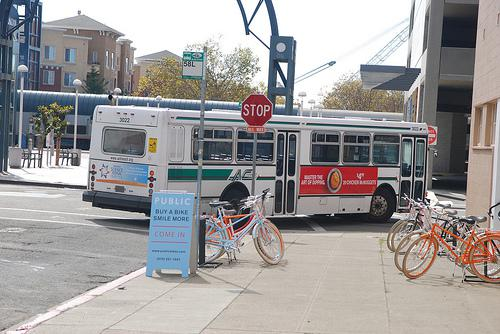Question: where is the bus?
Choices:
A. On the dirt.
B. On the street.
C. On the grass.
D. In the parking lot.
Answer with the letter. Answer: B Question: what does the red sign say?
Choices:
A. Stop.
B. Yield.
C. Slow.
D. One way.
Answer with the letter. Answer: A Question: how many bicycles are in the image?
Choices:
A. Two.
B. Four.
C. Five.
D. Six.
Answer with the letter. Answer: D 